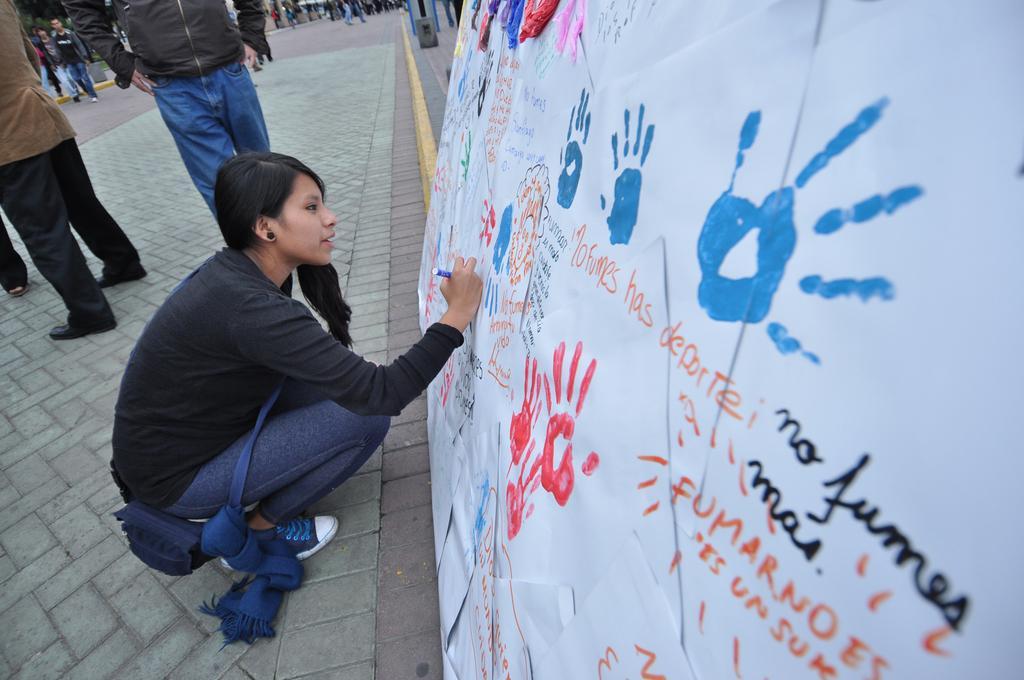How would you summarize this image in a sentence or two? This is the woman sitting in squat position and writing on the banner. This is a banner with the hand prints and letters on it. I can see groups of people standing. This looks like a pathway. 